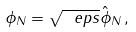Convert formula to latex. <formula><loc_0><loc_0><loc_500><loc_500>\phi _ { N } = \sqrt { \ e p s } \hat { \phi } _ { N } \, ,</formula> 